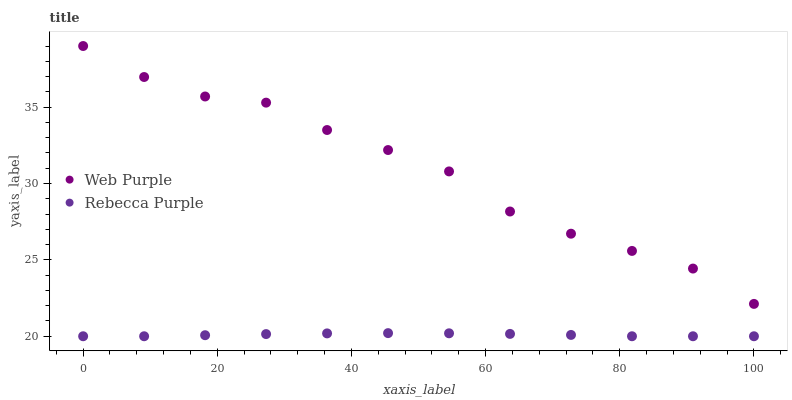Does Rebecca Purple have the minimum area under the curve?
Answer yes or no. Yes. Does Web Purple have the maximum area under the curve?
Answer yes or no. Yes. Does Rebecca Purple have the maximum area under the curve?
Answer yes or no. No. Is Rebecca Purple the smoothest?
Answer yes or no. Yes. Is Web Purple the roughest?
Answer yes or no. Yes. Is Rebecca Purple the roughest?
Answer yes or no. No. Does Rebecca Purple have the lowest value?
Answer yes or no. Yes. Does Web Purple have the highest value?
Answer yes or no. Yes. Does Rebecca Purple have the highest value?
Answer yes or no. No. Is Rebecca Purple less than Web Purple?
Answer yes or no. Yes. Is Web Purple greater than Rebecca Purple?
Answer yes or no. Yes. Does Rebecca Purple intersect Web Purple?
Answer yes or no. No. 